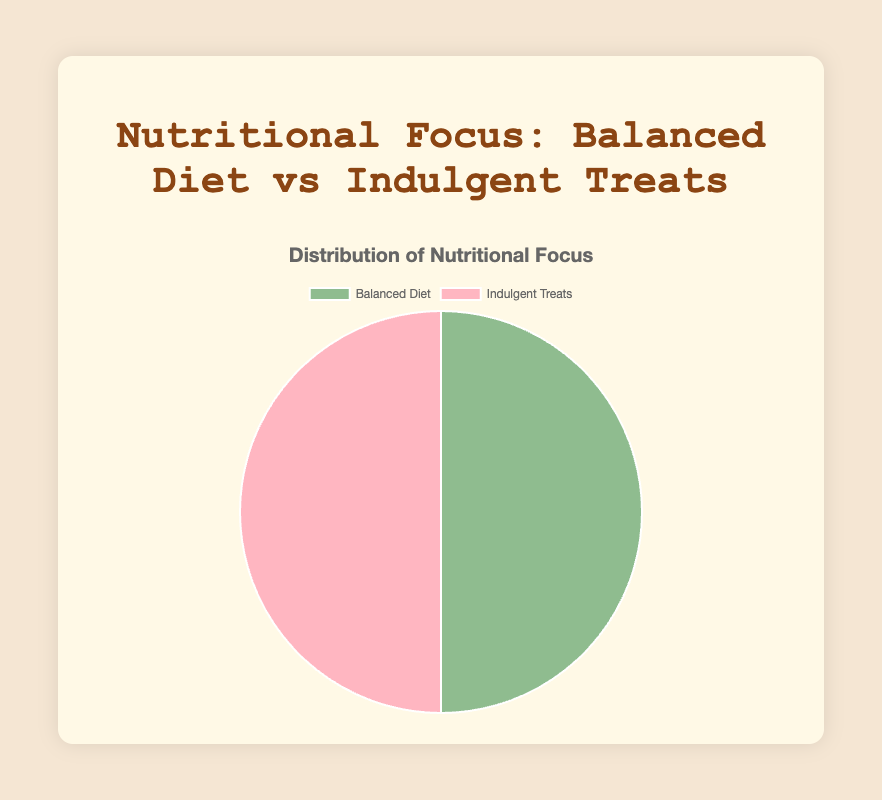What are the two categories displayed in the pie chart? The pie chart displays two categories which are clearly labeled in the legend. These categories are the main focus areas of the chart.
Answer: Balanced Diet and Indulgent Treats Which category has more examples? Both categories in the pie chart have an equal number of examples, as indicated by the equal proportions represented visually in the pie chart.
Answer: Both categories have an equal number of examples What is the visual difference in color between the two categories? The pie chart uses different background colors to distinguish between the categories. One segment is in a green color scheme, and the other is in a pink color scheme.
Answer: Green and Pink If Grilled Salmon was removed from the Balanced Diet category, what would the new proportion of the Balanced Diet category be? Removing one of the five items from the Balanced Diet category would result in 4 items remaining out of a total of 9 items. The new proportion for the Balanced Diet category would be 4/9.
Answer: 4/9 (approximately 44.4%) If two items were added to the Indulgent Treats category, how would the visual representation of the pie chart change? Adding two new items to the Indulgent Treats category would increase its total from 5 to 7. Therefore, Indulgent Treats would constitute 7 out of 12 items, and the pie chart would show a larger slice for Indulgent Treats.
Answer: Indulgent Treats slice would be larger Which category seems more calorie-dense based on item examples, Balanced Diet or Indulgent Treats? By observing the examples in each category, it's clear that items in the Indulgent Treats category have higher calorie counts compared to those in the Balanced Diet category.
Answer: Indulgent Treats What is the sum of protein grams for all items in the Balanced Diet category? Summing the protein grams of all Balanced Diet items: 22+8+6+31+5 = 72 grams.
Answer: 72 grams Comparing the average fat grams for each category, which one is less? First, calculate the average fat grams for each category. Sum of fat grams in Balanced Diet: 12+10+7+3.6+2 = 34.6, average = 34.6/5 = 6.92 g. Sum of fat grams in Indulgent Treats: 18+22+25+34+16 = 115, average = 115/5 = 23 g. The Balanced Diet category has a lower average fat grams.
Answer: Balanced Diet If we look at the bright colors in the pie chart, which nutritional focus do they represent? Bright colors typically draw more attention. The bright pink used in the chart represents Indulgent Treats as compared to the more muted green of Balanced Diet.
Answer: Indulgent Treats Considering only protein grams per serving, which individual example from both categories has the highest amount? Looking at the protein grams per serving in all examples from both categories, Chicken Breast in the Balanced Diet category has the highest with 31 grams.
Answer: Chicken Breast 